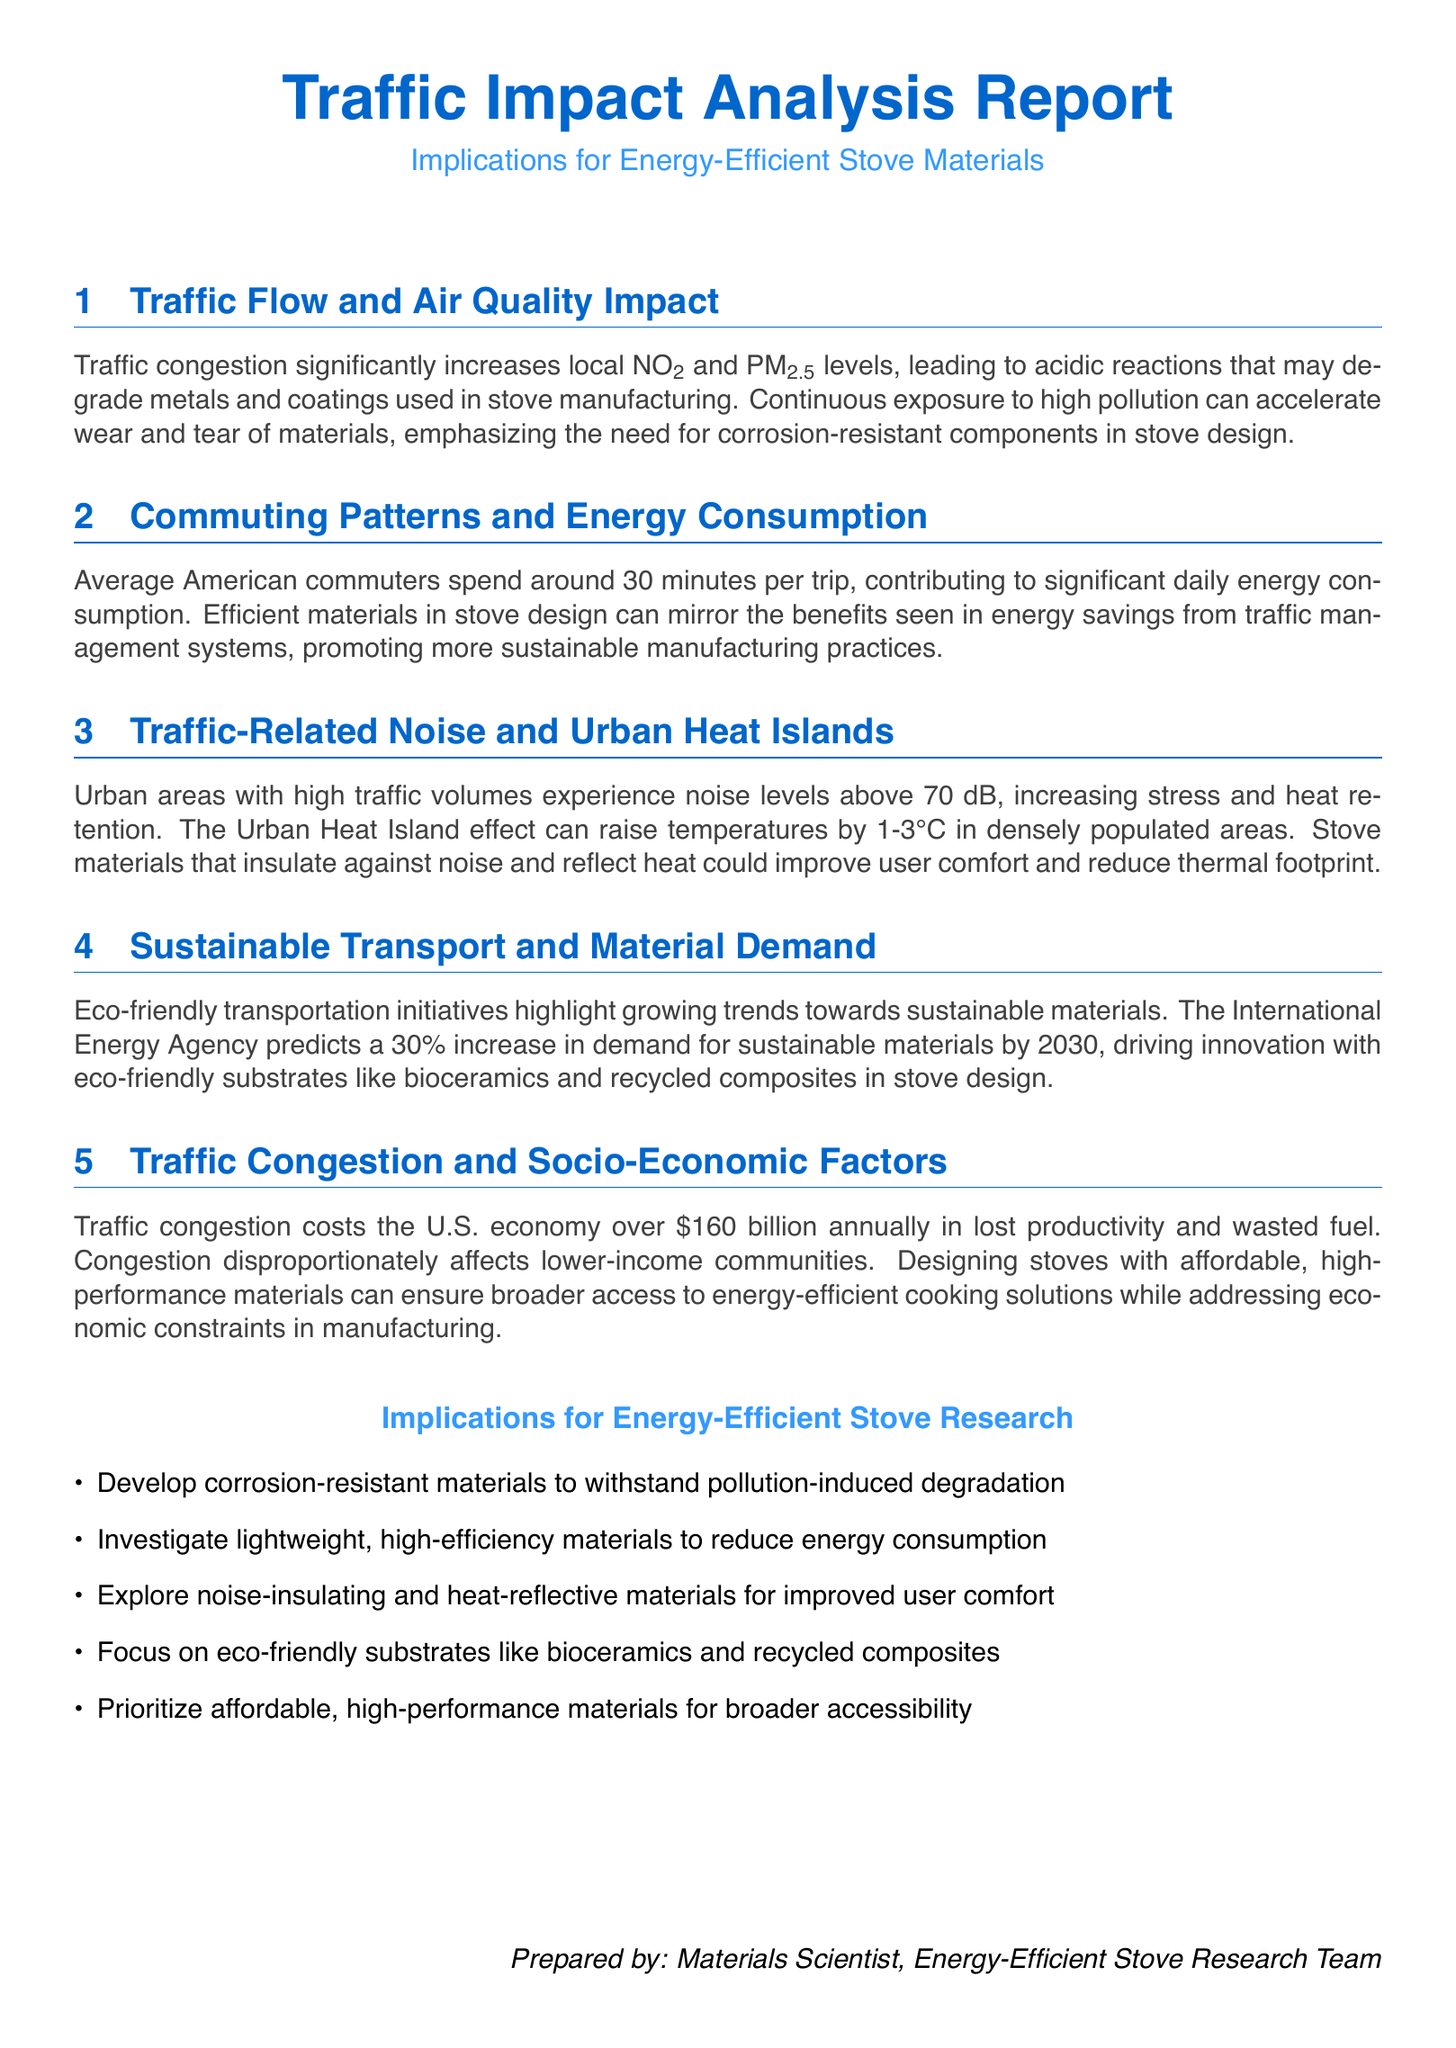What is the predicted increase in demand for sustainable materials by 2030? The document states that the International Energy Agency predicts a 30% increase in demand for sustainable materials by 2030.
Answer: 30% What contributes to significant daily energy consumption in commuting? The document mentions that average American commuters spend around 30 minutes per trip, contributing to significant daily energy consumption.
Answer: 30 minutes How much does traffic congestion cost the U.S. economy annually? The document specifies that traffic congestion costs the U.S. economy over $160 billion annually in lost productivity and wasted fuel.
Answer: $160 billion What is the impact of traffic congestion on socio-economic factors? The document indicates that congestion disproportionately affects lower-income communities.
Answer: lower-income communities Which materials are suggested for improving user comfort related to noise and heat? The document suggests exploring noise-insulating and heat-reflective materials for improved user comfort.
Answer: noise-insulating and heat-reflective materials What are the two materials mentioned as eco-friendly substrates in stove design? The document highlights bioceramics and recycled composites as examples of eco-friendly substrates.
Answer: bioceramics and recycled composites What is a significant air pollutant linked to traffic congestion in the report? The report mentions NO2 as a significant air pollutant linked to traffic congestion.
Answer: NO2 How much can the Urban Heat Island effect raise temperatures in populated areas? The document states that the Urban Heat Island effect can raise temperatures by 1-3°C in densely populated areas.
Answer: 1-3°C 